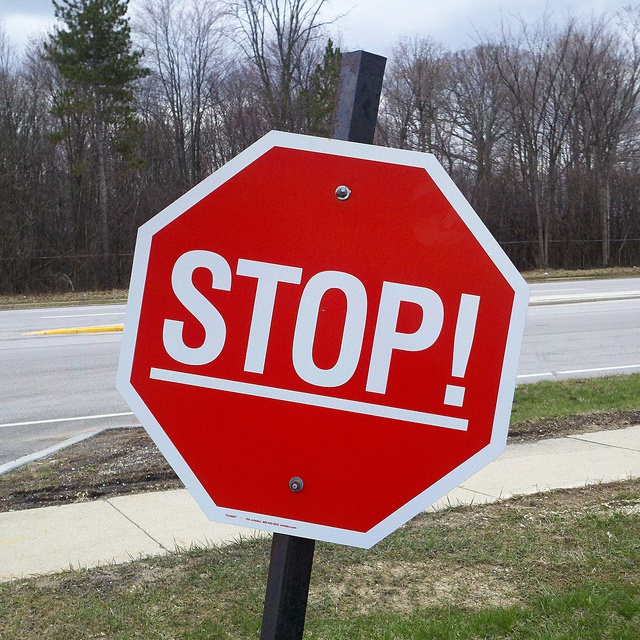Describe the objects in this image and their specific colors. I can see a stop sign in lightblue, brown, and lavender tones in this image. 